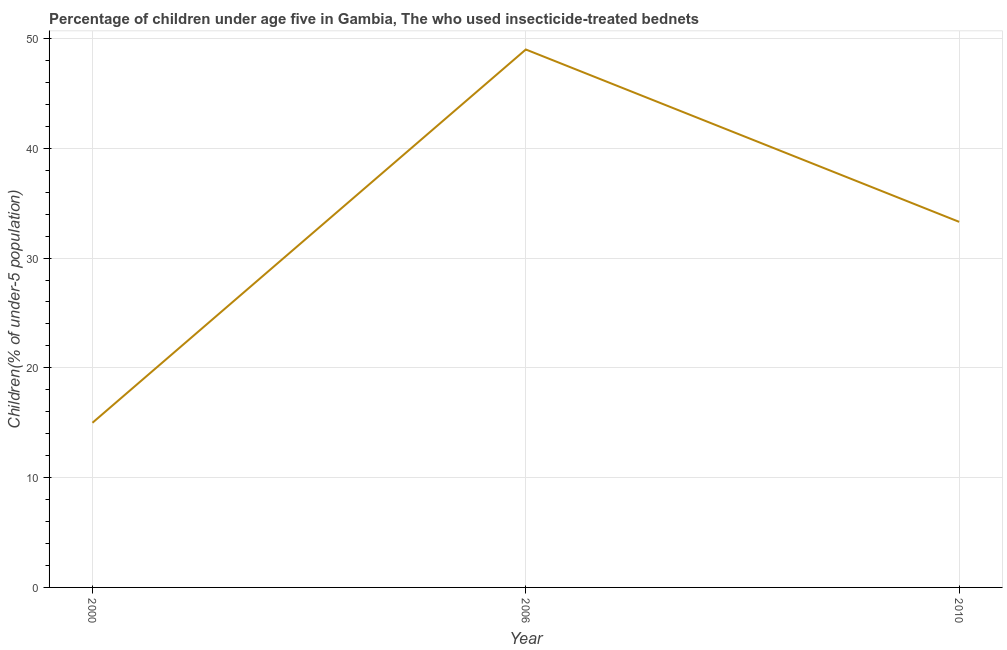What is the percentage of children who use of insecticide-treated bed nets in 2010?
Make the answer very short. 33.3. Across all years, what is the maximum percentage of children who use of insecticide-treated bed nets?
Make the answer very short. 49. Across all years, what is the minimum percentage of children who use of insecticide-treated bed nets?
Ensure brevity in your answer.  15. What is the sum of the percentage of children who use of insecticide-treated bed nets?
Your answer should be compact. 97.3. What is the difference between the percentage of children who use of insecticide-treated bed nets in 2000 and 2010?
Ensure brevity in your answer.  -18.3. What is the average percentage of children who use of insecticide-treated bed nets per year?
Ensure brevity in your answer.  32.43. What is the median percentage of children who use of insecticide-treated bed nets?
Your answer should be very brief. 33.3. In how many years, is the percentage of children who use of insecticide-treated bed nets greater than 38 %?
Keep it short and to the point. 1. Do a majority of the years between 2010 and 2006 (inclusive) have percentage of children who use of insecticide-treated bed nets greater than 40 %?
Provide a short and direct response. No. What is the ratio of the percentage of children who use of insecticide-treated bed nets in 2000 to that in 2010?
Your response must be concise. 0.45. What is the difference between the highest and the second highest percentage of children who use of insecticide-treated bed nets?
Keep it short and to the point. 15.7. Is the sum of the percentage of children who use of insecticide-treated bed nets in 2006 and 2010 greater than the maximum percentage of children who use of insecticide-treated bed nets across all years?
Offer a terse response. Yes. In how many years, is the percentage of children who use of insecticide-treated bed nets greater than the average percentage of children who use of insecticide-treated bed nets taken over all years?
Make the answer very short. 2. How many lines are there?
Your answer should be very brief. 1. What is the difference between two consecutive major ticks on the Y-axis?
Ensure brevity in your answer.  10. Does the graph contain any zero values?
Offer a very short reply. No. What is the title of the graph?
Provide a short and direct response. Percentage of children under age five in Gambia, The who used insecticide-treated bednets. What is the label or title of the Y-axis?
Offer a terse response. Children(% of under-5 population). What is the Children(% of under-5 population) of 2000?
Give a very brief answer. 15. What is the Children(% of under-5 population) in 2006?
Provide a short and direct response. 49. What is the Children(% of under-5 population) in 2010?
Offer a terse response. 33.3. What is the difference between the Children(% of under-5 population) in 2000 and 2006?
Ensure brevity in your answer.  -34. What is the difference between the Children(% of under-5 population) in 2000 and 2010?
Your answer should be very brief. -18.3. What is the difference between the Children(% of under-5 population) in 2006 and 2010?
Keep it short and to the point. 15.7. What is the ratio of the Children(% of under-5 population) in 2000 to that in 2006?
Make the answer very short. 0.31. What is the ratio of the Children(% of under-5 population) in 2000 to that in 2010?
Keep it short and to the point. 0.45. What is the ratio of the Children(% of under-5 population) in 2006 to that in 2010?
Your answer should be very brief. 1.47. 